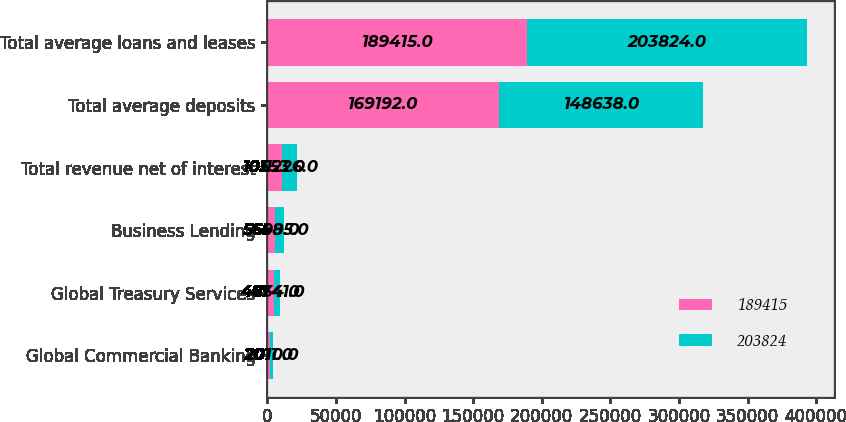Convert chart to OTSL. <chart><loc_0><loc_0><loc_500><loc_500><stacked_bar_chart><ecel><fcel>Global Commercial Banking<fcel>Global Treasury Services<fcel>Business Lending<fcel>Total revenue net of interest<fcel>Total average deposits<fcel>Total average loans and leases<nl><fcel>189415<fcel>2011<fcel>4854<fcel>5699<fcel>10553<fcel>169192<fcel>189415<nl><fcel>203824<fcel>2010<fcel>4741<fcel>6485<fcel>11226<fcel>148638<fcel>203824<nl></chart> 